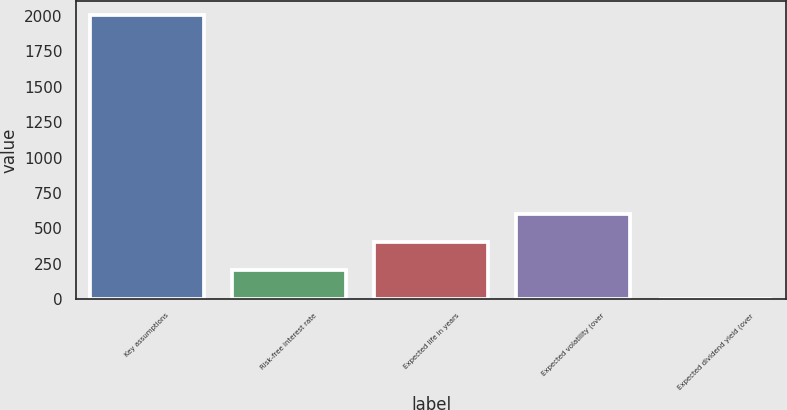Convert chart to OTSL. <chart><loc_0><loc_0><loc_500><loc_500><bar_chart><fcel>Key assumptions<fcel>Risk-free interest rate<fcel>Expected life in years<fcel>Expected volatility (over<fcel>Expected dividend yield (over<nl><fcel>2006<fcel>203.48<fcel>403.76<fcel>604.04<fcel>3.2<nl></chart> 